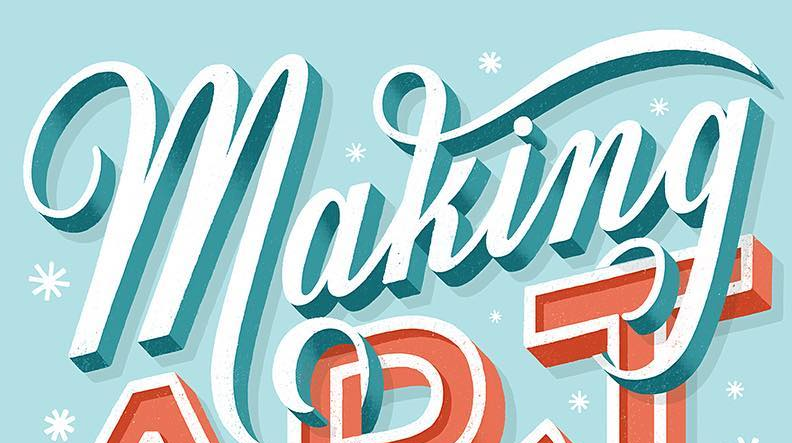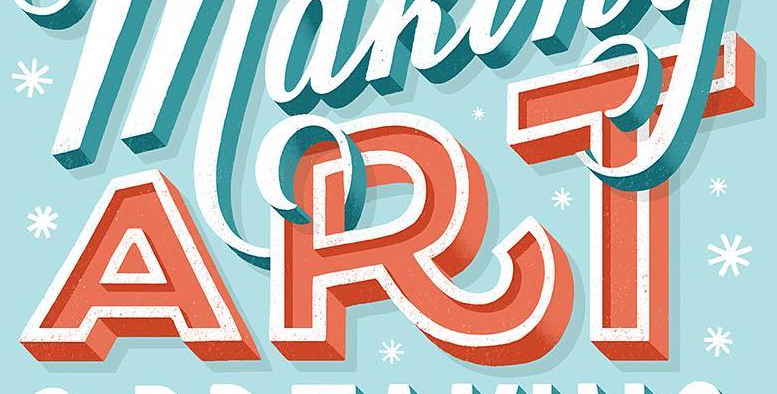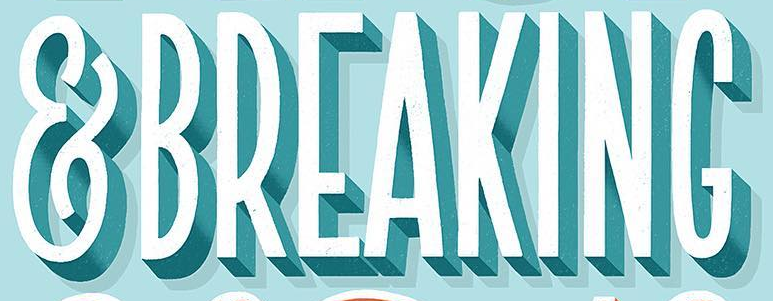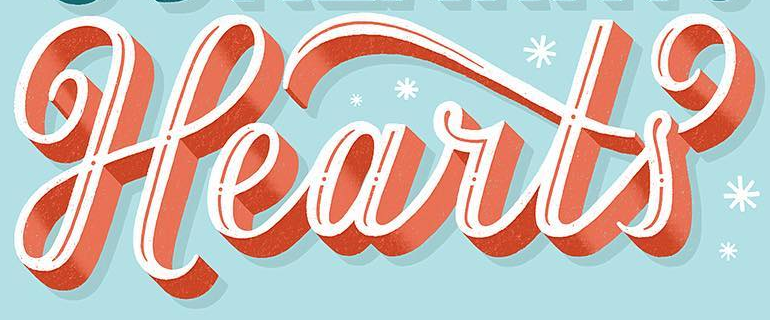Identify the words shown in these images in order, separated by a semicolon. making; ART; &BREAKING; Hearts 